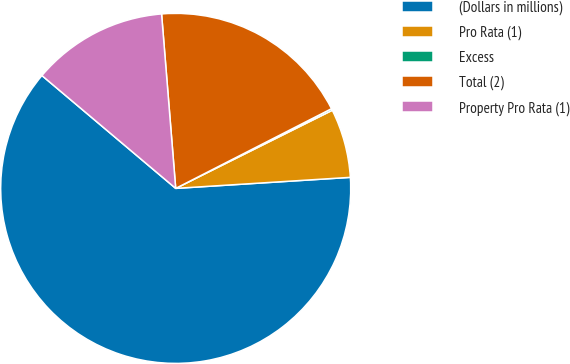Convert chart. <chart><loc_0><loc_0><loc_500><loc_500><pie_chart><fcel>(Dollars in millions)<fcel>Pro Rata (1)<fcel>Excess<fcel>Total (2)<fcel>Property Pro Rata (1)<nl><fcel>62.15%<fcel>6.36%<fcel>0.16%<fcel>18.76%<fcel>12.56%<nl></chart> 